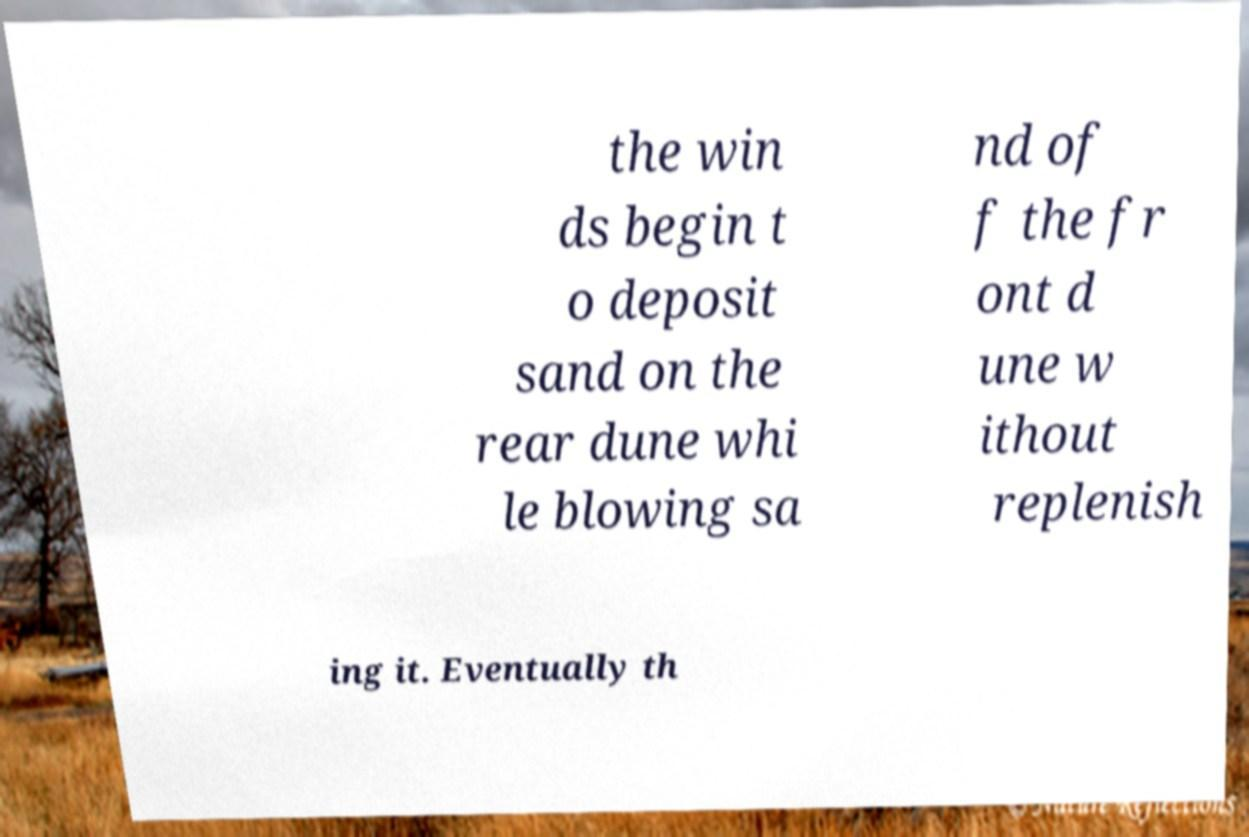What messages or text are displayed in this image? I need them in a readable, typed format. the win ds begin t o deposit sand on the rear dune whi le blowing sa nd of f the fr ont d une w ithout replenish ing it. Eventually th 